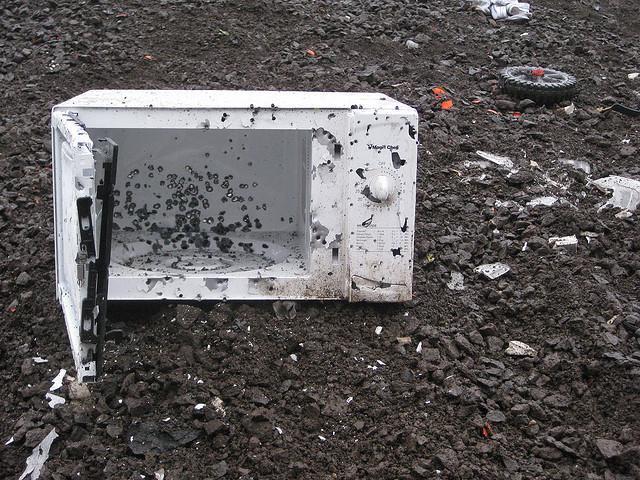How many people are sitting on the bench?
Give a very brief answer. 0. 